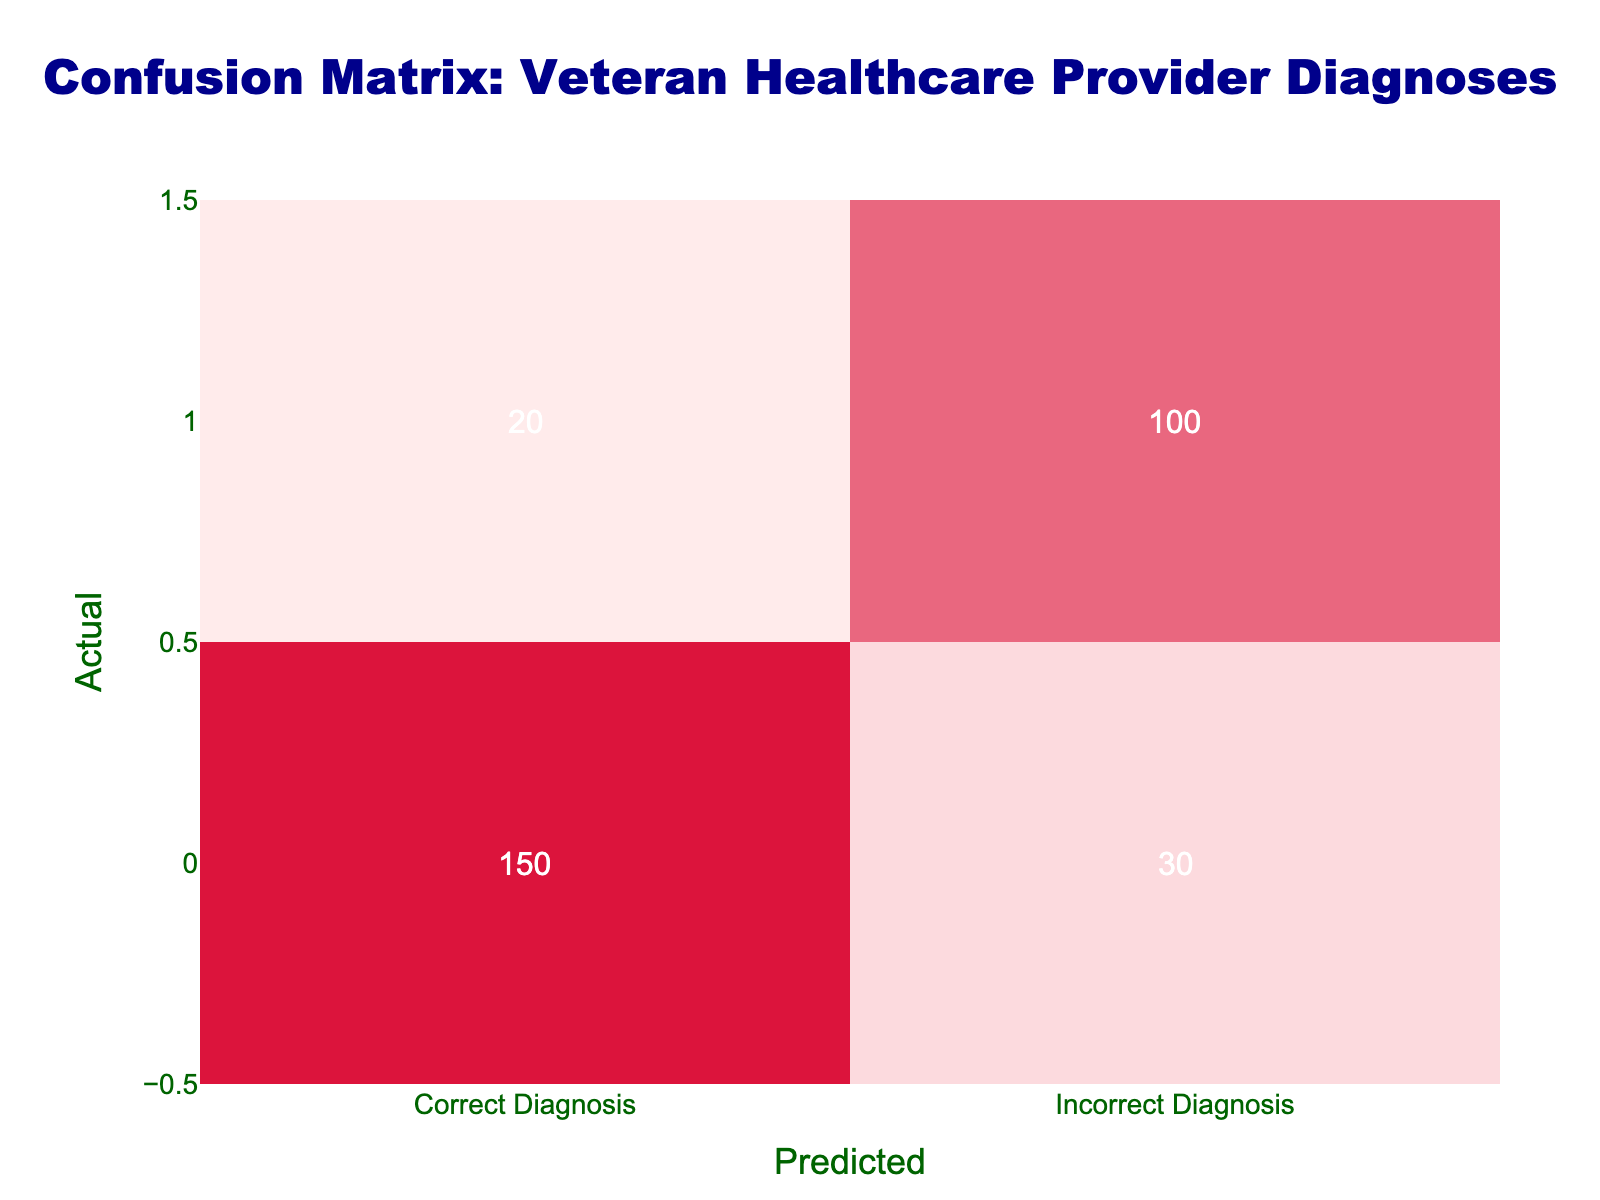What is the number of true positives in the diagnoses? The true positives are represented in the cell where the Actual Diagnosis is "Correct Diagnosis" and the Predicted Diagnosis is also "Correct Diagnosis." From the table, this value is 150.
Answer: 150 How many diagnoses were misclassified as incorrect? The number of diagnoses that were incorrectly classified is shown in the cell where the Actual Diagnosis is "Correct Diagnosis" but the Predicted Diagnosis is "Incorrect Diagnosis." From the table, this value is 30.
Answer: 30 What is the total number of diagnoses made by veteran healthcare providers? To find the total diagnoses, we sum all the values in the table. The calculation is (150 + 30 + 20 + 100) = 300.
Answer: 300 What percentage of diagnoses were true positives? First, we found that there are 150 true positives and a total of 300 diagnoses. The percentage is calculated as (150 / 300) * 100 = 50%.
Answer: 50% Is it true that there were more incorrect diagnoses than correct diagnoses? We can compare the values of "Incorrect Diagnosis" in both the "Correct Diagnosis" and "Incorrect Diagnosis" rows. The value for "Correct Diagnosis" is 30, and for "Incorrect Diagnosis" is 100. Since 100 is greater than 30, the statement is true.
Answer: Yes How many false negatives were identified in the diagnoses? The false negatives are located in the row of "Incorrect Diagnosis" and the column of "Correct Diagnosis," which is 20.
Answer: 20 What is the difference between the number of true positives and false negatives? We have 150 true positives and 20 false negatives. The difference is calculated as (150 - 20) = 130.
Answer: 130 If the total misdiagnosis happened in two categories, what is the total number of misdiagnoses? The total misdiagnoses are the sum of the incorrect diagnoses: 30 (misclassified as incorrect from actual correct) and 20 (misclassified from actual incorrect); thus, (30 + 20) = 50.
Answer: 50 What is the ratio of true positives to the total number of misdiagnoses? First, we identified that there are 150 true positives and 50 total misdiagnoses. Therefore, the ratio is (150 / 50) = 3.
Answer: 3 